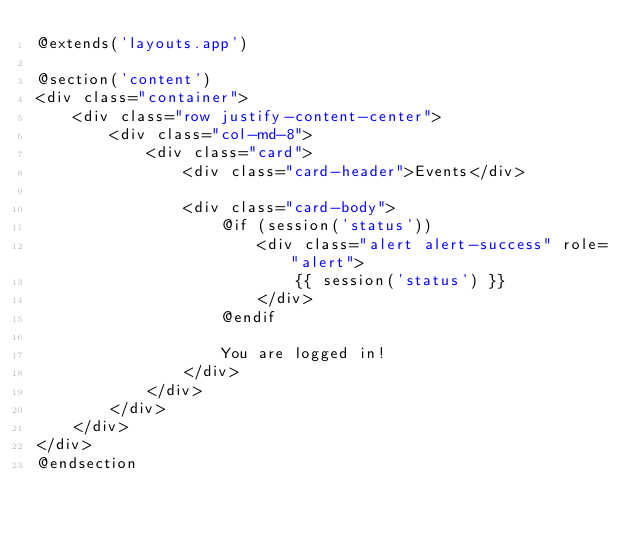<code> <loc_0><loc_0><loc_500><loc_500><_PHP_>@extends('layouts.app')

@section('content')
<div class="container">
    <div class="row justify-content-center">
        <div class="col-md-8">
            <div class="card">
                <div class="card-header">Events</div>

                <div class="card-body">
                    @if (session('status'))
                        <div class="alert alert-success" role="alert">
                            {{ session('status') }}
                        </div>
                    @endif

                    You are logged in!
                </div>
            </div>
        </div>
    </div>
</div>
@endsection
</code> 